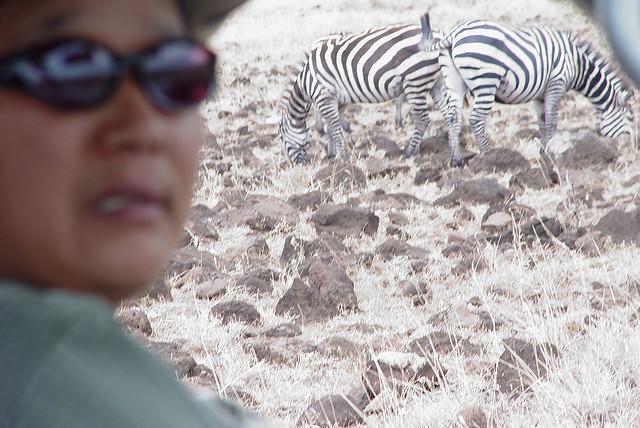How many zebras are here?
Give a very brief answer. 2. How many zebras are there?
Give a very brief answer. 2. How many boats are docked at this pier?
Give a very brief answer. 0. 